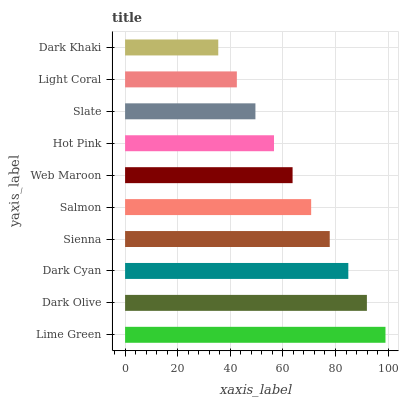Is Dark Khaki the minimum?
Answer yes or no. Yes. Is Lime Green the maximum?
Answer yes or no. Yes. Is Dark Olive the minimum?
Answer yes or no. No. Is Dark Olive the maximum?
Answer yes or no. No. Is Lime Green greater than Dark Olive?
Answer yes or no. Yes. Is Dark Olive less than Lime Green?
Answer yes or no. Yes. Is Dark Olive greater than Lime Green?
Answer yes or no. No. Is Lime Green less than Dark Olive?
Answer yes or no. No. Is Salmon the high median?
Answer yes or no. Yes. Is Web Maroon the low median?
Answer yes or no. Yes. Is Sienna the high median?
Answer yes or no. No. Is Sienna the low median?
Answer yes or no. No. 